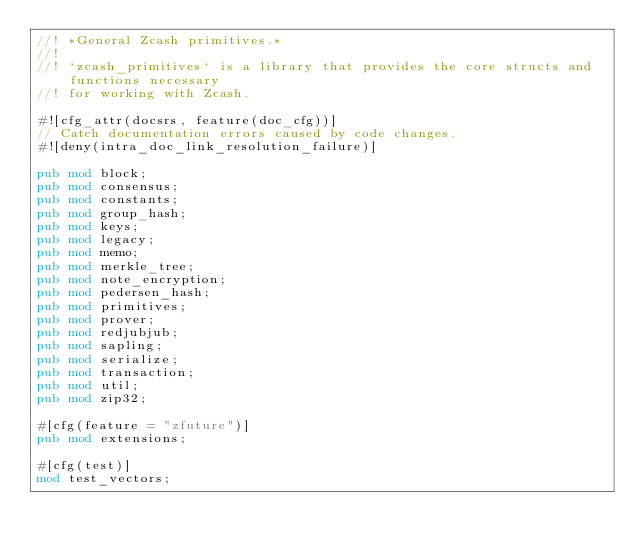Convert code to text. <code><loc_0><loc_0><loc_500><loc_500><_Rust_>//! *General Zcash primitives.*
//!
//! `zcash_primitives` is a library that provides the core structs and functions necessary
//! for working with Zcash.

#![cfg_attr(docsrs, feature(doc_cfg))]
// Catch documentation errors caused by code changes.
#![deny(intra_doc_link_resolution_failure)]

pub mod block;
pub mod consensus;
pub mod constants;
pub mod group_hash;
pub mod keys;
pub mod legacy;
pub mod memo;
pub mod merkle_tree;
pub mod note_encryption;
pub mod pedersen_hash;
pub mod primitives;
pub mod prover;
pub mod redjubjub;
pub mod sapling;
pub mod serialize;
pub mod transaction;
pub mod util;
pub mod zip32;

#[cfg(feature = "zfuture")]
pub mod extensions;

#[cfg(test)]
mod test_vectors;
</code> 